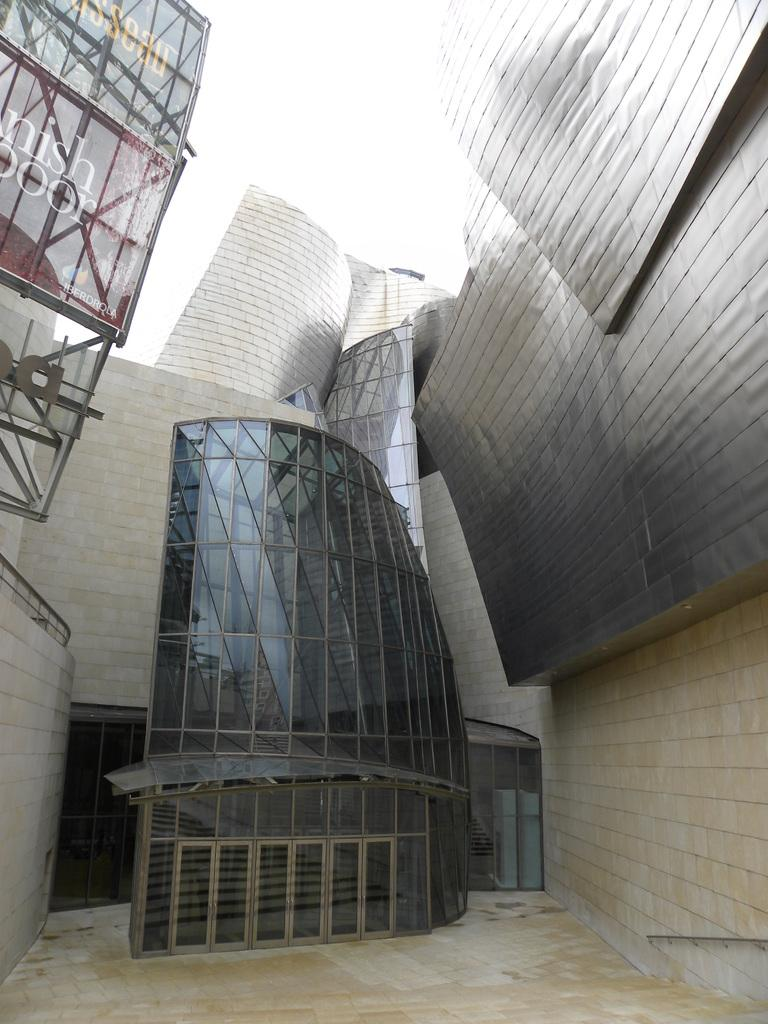What type of structure is present in the image? There is a building in the image. What else can be seen in the image besides the building? There are objects in the image. What can be seen in the background of the image? The sky is visible in the background of the image. Where is the toothpaste located in the image? There is no toothpaste present in the image. What type of cushion can be seen on the building in the image? There is no cushion present on the building in the image. 